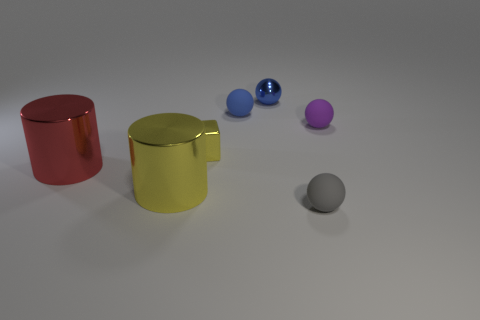There is a cylinder that is the same color as the small shiny cube; what size is it?
Ensure brevity in your answer.  Large. What number of balls are behind the purple rubber object that is right of the yellow object that is in front of the red cylinder?
Give a very brief answer. 2. Is there a large metal cylinder that has the same color as the cube?
Give a very brief answer. Yes. There is a cube that is the same size as the blue rubber ball; what is its color?
Keep it short and to the point. Yellow. Is there another metallic thing of the same shape as the gray thing?
Your response must be concise. Yes. The metallic object that is the same color as the small metallic block is what shape?
Ensure brevity in your answer.  Cylinder. Are there any large yellow objects in front of the small rubber sphere that is on the left side of the tiny thing in front of the big yellow object?
Your answer should be very brief. Yes. The other blue object that is the same size as the blue rubber thing is what shape?
Give a very brief answer. Sphere. What color is the other big shiny thing that is the same shape as the large red shiny thing?
Give a very brief answer. Yellow. How many things are small yellow matte cylinders or small yellow things?
Offer a very short reply. 1. 